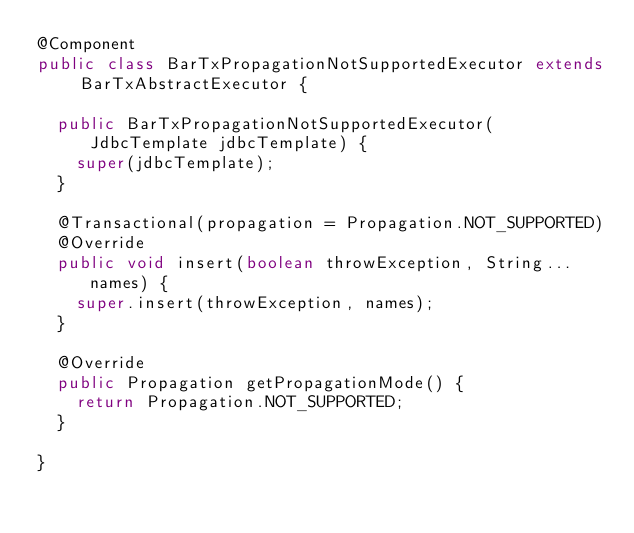Convert code to text. <code><loc_0><loc_0><loc_500><loc_500><_Java_>@Component
public class BarTxPropagationNotSupportedExecutor extends BarTxAbstractExecutor {

  public BarTxPropagationNotSupportedExecutor(JdbcTemplate jdbcTemplate) {
    super(jdbcTemplate);
  }

  @Transactional(propagation = Propagation.NOT_SUPPORTED)
  @Override
  public void insert(boolean throwException, String... names) {
    super.insert(throwException, names);
  }

  @Override
  public Propagation getPropagationMode() {
    return Propagation.NOT_SUPPORTED;
  }

}
</code> 